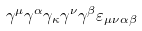<formula> <loc_0><loc_0><loc_500><loc_500>\gamma ^ { \mu } \gamma ^ { \alpha } \gamma _ { \kappa } \gamma ^ { \nu } \gamma ^ { \beta } \varepsilon _ { \mu \nu \alpha \beta }</formula> 